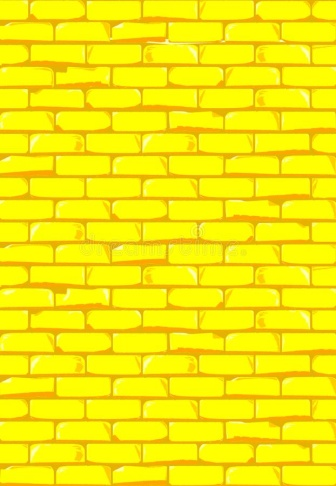Can this image of a yellow brick wall be used metaphorically in art or literature? How? Absolutely, the yellow brick wall can serve as a powerful metaphor in art and literature. It could represent barriers both physical and emotional, or pathways to new beginnings, echoing the themes of transformation or journey. In literature, such imagery could evoke themes of overcoming obstacles or the brightness of new opportunities ahead, akin to the 'yellow brick road' from 'The Wizard of Oz.' 